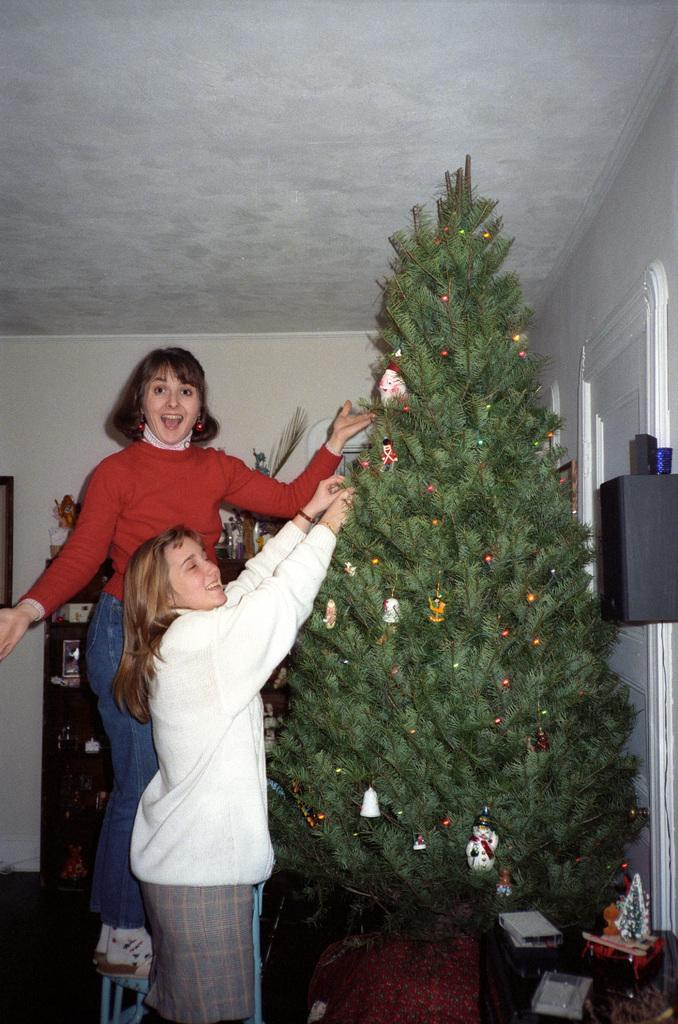How many women are in the image? There are two women standing in the image. What is the facial expression of the women? The women are smiling. What can be seen in the image besides the women? There is a speaker, a Christmas tree, a rack, a frame on the wall, and some unspecified objects in the image. What part of a building is visible in the image? A: The image includes a roof. What type of advertisement can be seen on the wall in the image? There is no advertisement present on the wall in the image; only a frame is visible. What kind of noise is being made by the pear in the image? There is no pear present in the image, and therefore no noise can be attributed to it. 